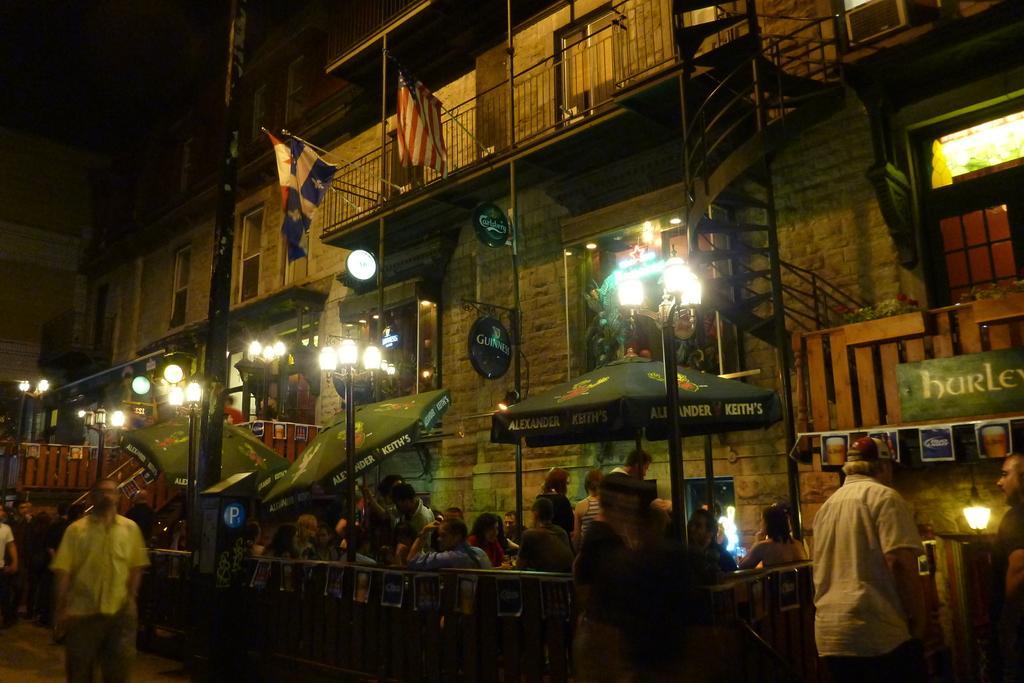How would you summarize this image in a sentence or two? In this picture I can see building, few lights to the poles and I can see umbrellas with some text. I can see few people sitting and few are walking and I can see couple of flags. 